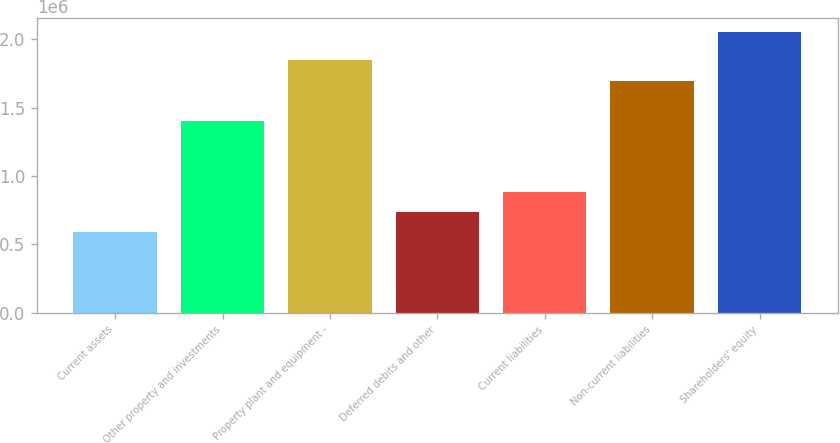Convert chart. <chart><loc_0><loc_0><loc_500><loc_500><bar_chart><fcel>Current assets<fcel>Other property and investments<fcel>Property plant and equipment -<fcel>Deferred debits and other<fcel>Current liabilities<fcel>Non-current liabilities<fcel>Shareholders' equity<nl><fcel>590580<fcel>1.40322e+06<fcel>1.85048e+06<fcel>736507<fcel>882433<fcel>1.69409e+06<fcel>2.04985e+06<nl></chart> 